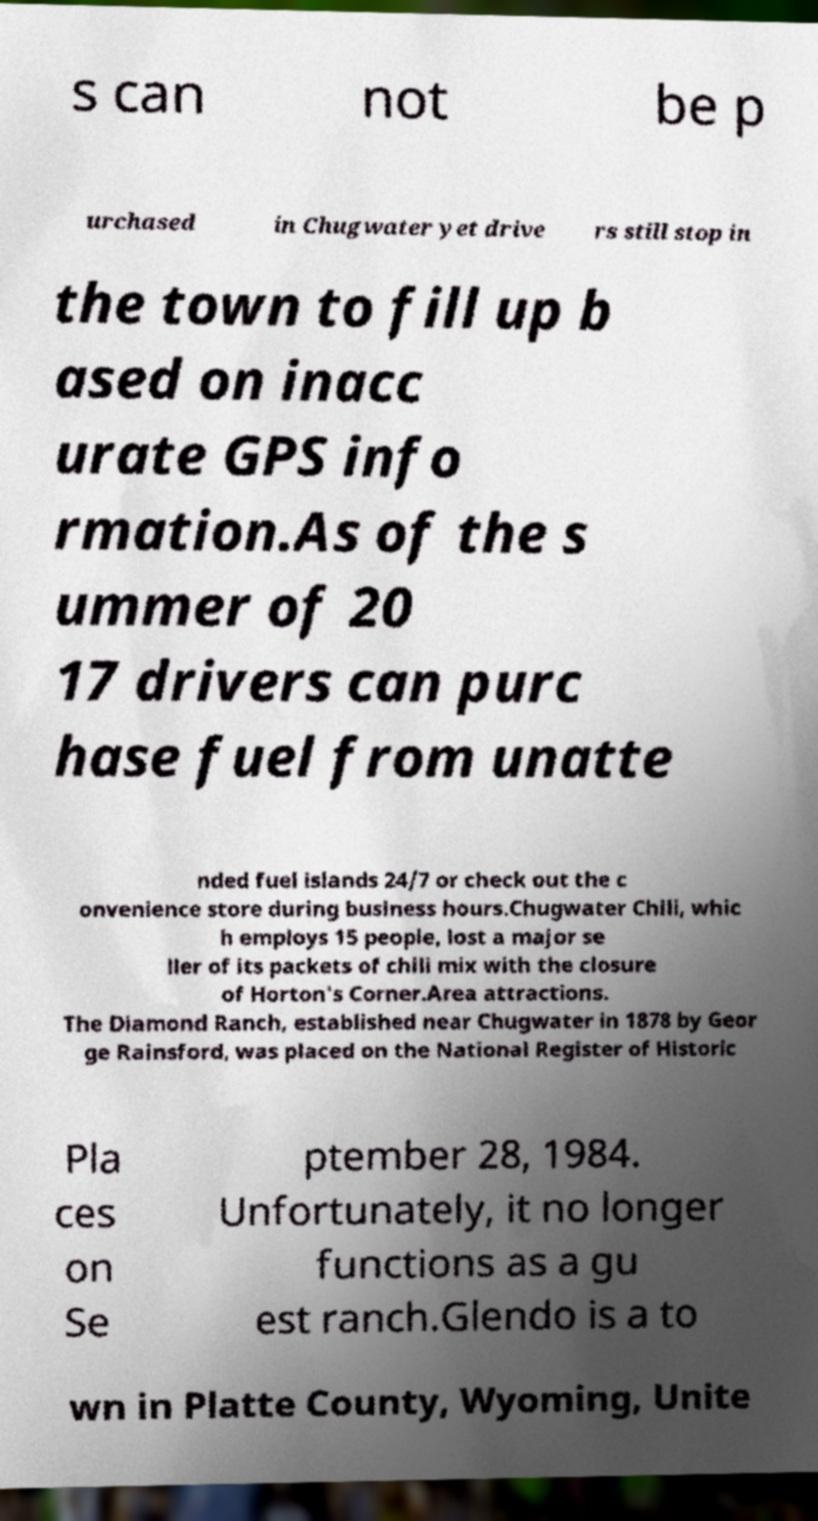Please identify and transcribe the text found in this image. s can not be p urchased in Chugwater yet drive rs still stop in the town to fill up b ased on inacc urate GPS info rmation.As of the s ummer of 20 17 drivers can purc hase fuel from unatte nded fuel islands 24/7 or check out the c onvenience store during business hours.Chugwater Chili, whic h employs 15 people, lost a major se ller of its packets of chili mix with the closure of Horton's Corner.Area attractions. The Diamond Ranch, established near Chugwater in 1878 by Geor ge Rainsford, was placed on the National Register of Historic Pla ces on Se ptember 28, 1984. Unfortunately, it no longer functions as a gu est ranch.Glendo is a to wn in Platte County, Wyoming, Unite 